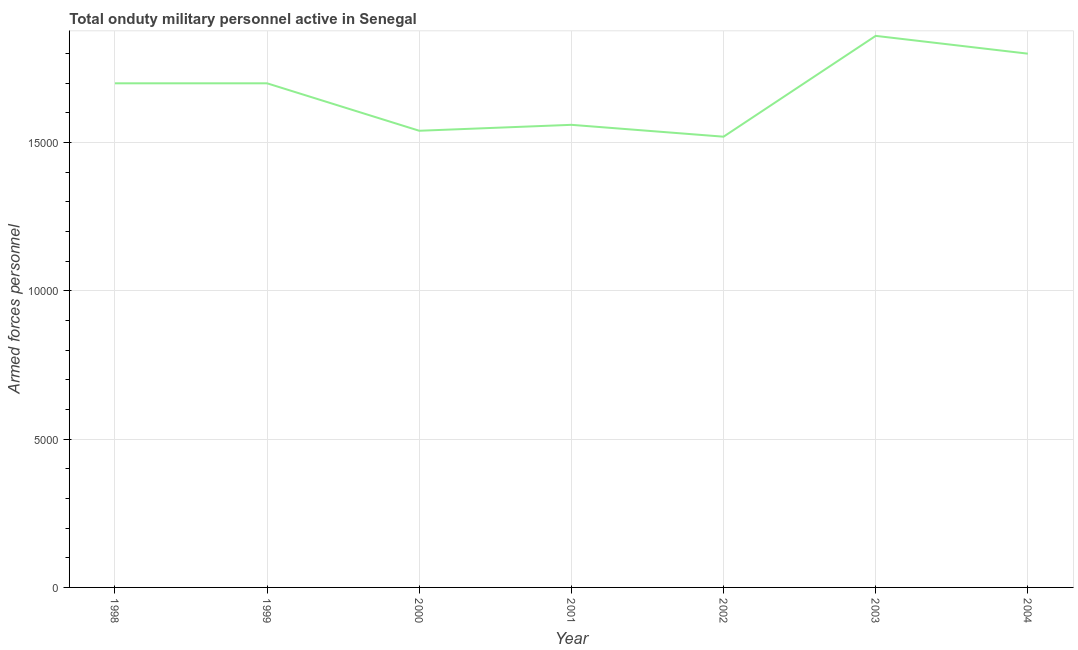What is the number of armed forces personnel in 2000?
Your answer should be compact. 1.54e+04. Across all years, what is the maximum number of armed forces personnel?
Make the answer very short. 1.86e+04. Across all years, what is the minimum number of armed forces personnel?
Keep it short and to the point. 1.52e+04. In which year was the number of armed forces personnel minimum?
Offer a very short reply. 2002. What is the sum of the number of armed forces personnel?
Your response must be concise. 1.17e+05. What is the difference between the number of armed forces personnel in 2000 and 2004?
Offer a terse response. -2600. What is the average number of armed forces personnel per year?
Your response must be concise. 1.67e+04. What is the median number of armed forces personnel?
Provide a succinct answer. 1.70e+04. Do a majority of the years between 2001 and 2003 (inclusive) have number of armed forces personnel greater than 13000 ?
Provide a short and direct response. Yes. What is the ratio of the number of armed forces personnel in 1998 to that in 2002?
Give a very brief answer. 1.12. Is the number of armed forces personnel in 2002 less than that in 2004?
Ensure brevity in your answer.  Yes. Is the difference between the number of armed forces personnel in 1999 and 2004 greater than the difference between any two years?
Offer a terse response. No. What is the difference between the highest and the second highest number of armed forces personnel?
Your response must be concise. 600. What is the difference between the highest and the lowest number of armed forces personnel?
Your answer should be very brief. 3400. Does the number of armed forces personnel monotonically increase over the years?
Offer a very short reply. No. Are the values on the major ticks of Y-axis written in scientific E-notation?
Your answer should be compact. No. What is the title of the graph?
Your response must be concise. Total onduty military personnel active in Senegal. What is the label or title of the Y-axis?
Offer a very short reply. Armed forces personnel. What is the Armed forces personnel of 1998?
Keep it short and to the point. 1.70e+04. What is the Armed forces personnel in 1999?
Offer a very short reply. 1.70e+04. What is the Armed forces personnel in 2000?
Your response must be concise. 1.54e+04. What is the Armed forces personnel of 2001?
Provide a succinct answer. 1.56e+04. What is the Armed forces personnel in 2002?
Keep it short and to the point. 1.52e+04. What is the Armed forces personnel of 2003?
Provide a short and direct response. 1.86e+04. What is the Armed forces personnel in 2004?
Your response must be concise. 1.80e+04. What is the difference between the Armed forces personnel in 1998 and 1999?
Keep it short and to the point. 0. What is the difference between the Armed forces personnel in 1998 and 2000?
Your answer should be very brief. 1600. What is the difference between the Armed forces personnel in 1998 and 2001?
Your answer should be compact. 1400. What is the difference between the Armed forces personnel in 1998 and 2002?
Your answer should be compact. 1800. What is the difference between the Armed forces personnel in 1998 and 2003?
Offer a very short reply. -1600. What is the difference between the Armed forces personnel in 1998 and 2004?
Provide a short and direct response. -1000. What is the difference between the Armed forces personnel in 1999 and 2000?
Provide a succinct answer. 1600. What is the difference between the Armed forces personnel in 1999 and 2001?
Ensure brevity in your answer.  1400. What is the difference between the Armed forces personnel in 1999 and 2002?
Provide a succinct answer. 1800. What is the difference between the Armed forces personnel in 1999 and 2003?
Give a very brief answer. -1600. What is the difference between the Armed forces personnel in 1999 and 2004?
Provide a succinct answer. -1000. What is the difference between the Armed forces personnel in 2000 and 2001?
Give a very brief answer. -200. What is the difference between the Armed forces personnel in 2000 and 2003?
Offer a terse response. -3200. What is the difference between the Armed forces personnel in 2000 and 2004?
Your response must be concise. -2600. What is the difference between the Armed forces personnel in 2001 and 2003?
Ensure brevity in your answer.  -3000. What is the difference between the Armed forces personnel in 2001 and 2004?
Offer a very short reply. -2400. What is the difference between the Armed forces personnel in 2002 and 2003?
Your answer should be very brief. -3400. What is the difference between the Armed forces personnel in 2002 and 2004?
Your response must be concise. -2800. What is the difference between the Armed forces personnel in 2003 and 2004?
Provide a short and direct response. 600. What is the ratio of the Armed forces personnel in 1998 to that in 2000?
Offer a very short reply. 1.1. What is the ratio of the Armed forces personnel in 1998 to that in 2001?
Your answer should be compact. 1.09. What is the ratio of the Armed forces personnel in 1998 to that in 2002?
Provide a succinct answer. 1.12. What is the ratio of the Armed forces personnel in 1998 to that in 2003?
Give a very brief answer. 0.91. What is the ratio of the Armed forces personnel in 1998 to that in 2004?
Give a very brief answer. 0.94. What is the ratio of the Armed forces personnel in 1999 to that in 2000?
Your answer should be very brief. 1.1. What is the ratio of the Armed forces personnel in 1999 to that in 2001?
Your response must be concise. 1.09. What is the ratio of the Armed forces personnel in 1999 to that in 2002?
Offer a terse response. 1.12. What is the ratio of the Armed forces personnel in 1999 to that in 2003?
Provide a succinct answer. 0.91. What is the ratio of the Armed forces personnel in 1999 to that in 2004?
Give a very brief answer. 0.94. What is the ratio of the Armed forces personnel in 2000 to that in 2001?
Your response must be concise. 0.99. What is the ratio of the Armed forces personnel in 2000 to that in 2002?
Provide a short and direct response. 1.01. What is the ratio of the Armed forces personnel in 2000 to that in 2003?
Give a very brief answer. 0.83. What is the ratio of the Armed forces personnel in 2000 to that in 2004?
Offer a very short reply. 0.86. What is the ratio of the Armed forces personnel in 2001 to that in 2002?
Offer a terse response. 1.03. What is the ratio of the Armed forces personnel in 2001 to that in 2003?
Provide a succinct answer. 0.84. What is the ratio of the Armed forces personnel in 2001 to that in 2004?
Make the answer very short. 0.87. What is the ratio of the Armed forces personnel in 2002 to that in 2003?
Give a very brief answer. 0.82. What is the ratio of the Armed forces personnel in 2002 to that in 2004?
Your answer should be very brief. 0.84. What is the ratio of the Armed forces personnel in 2003 to that in 2004?
Offer a very short reply. 1.03. 